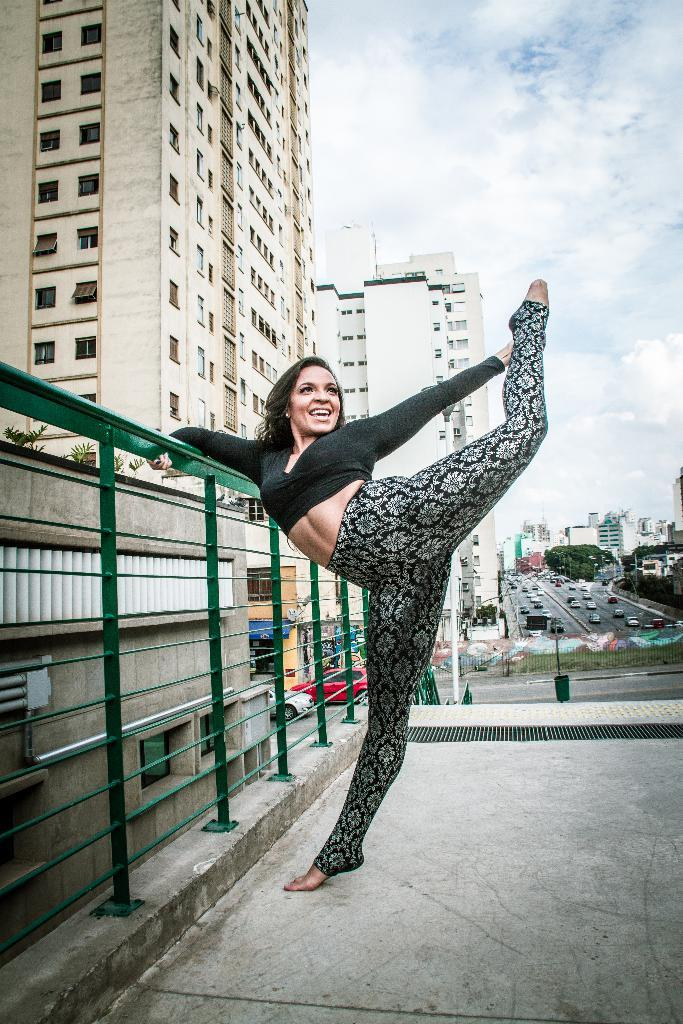Who is present in the image? There is a woman in the image. What is the woman wearing? The woman is wearing a black dress. What can be seen in the background of the image? There are buildings, cars, trees, and the sky visible in the background of the image. What is the condition of the sky in the image? The sky is visible at the top of the image, and clouds are present in the sky. What type of coach can be seen in the image? There is no coach present in the image. Is the woman holding a camera in the image? The image does not show the woman holding a camera. 